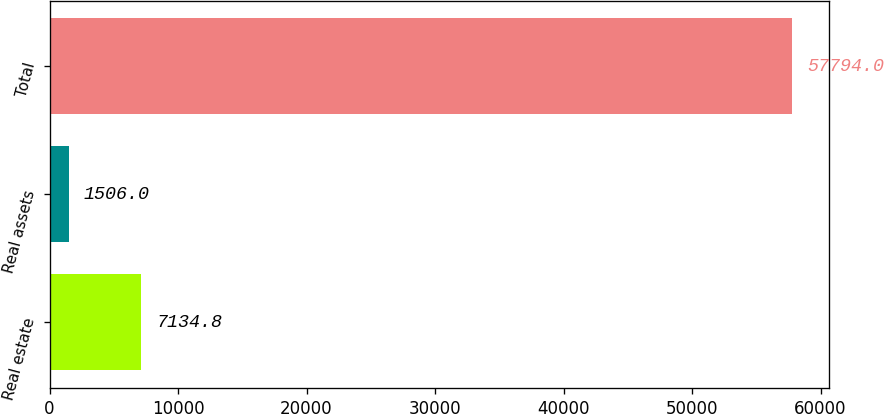<chart> <loc_0><loc_0><loc_500><loc_500><bar_chart><fcel>Real estate<fcel>Real assets<fcel>Total<nl><fcel>7134.8<fcel>1506<fcel>57794<nl></chart> 